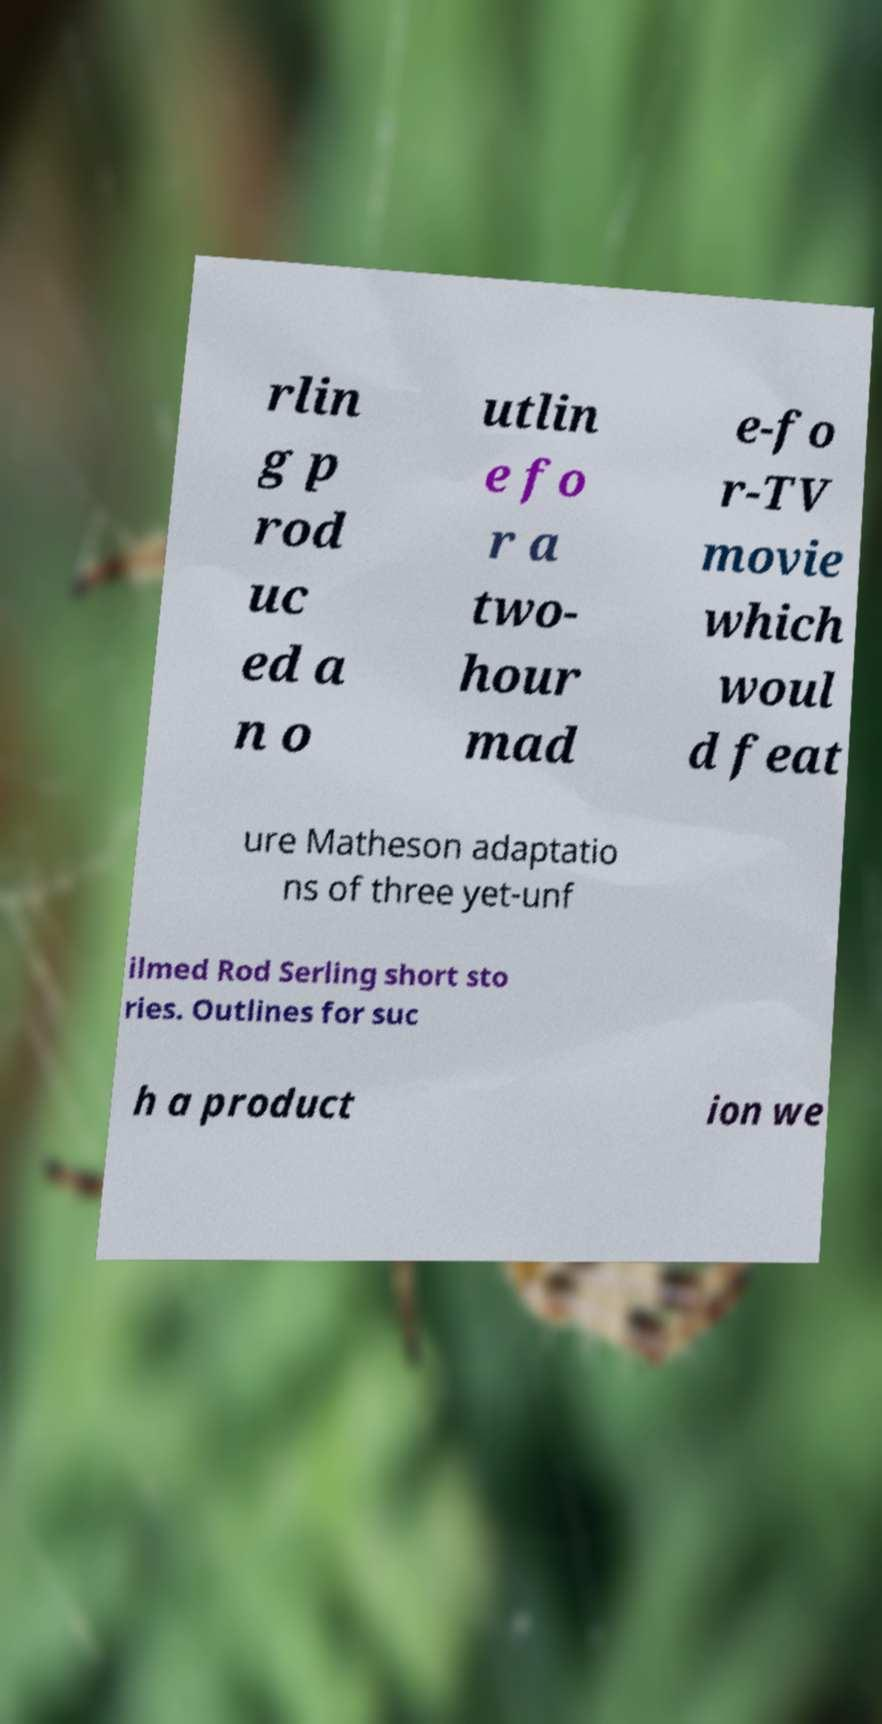Please read and relay the text visible in this image. What does it say? rlin g p rod uc ed a n o utlin e fo r a two- hour mad e-fo r-TV movie which woul d feat ure Matheson adaptatio ns of three yet-unf ilmed Rod Serling short sto ries. Outlines for suc h a product ion we 